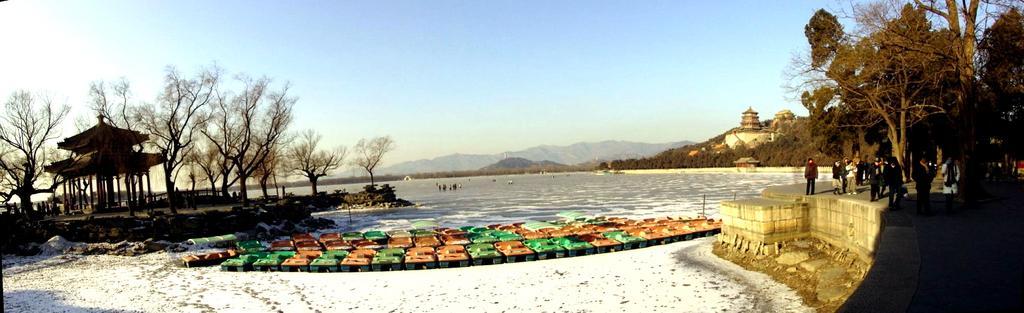Describe this image in one or two sentences. On the right side there is a pavement on that pavement people are standing and there are trees and there is the sea and there are few objects near the sea, on the left side there are trees and a shelter, in the background there are mountains and the sky. 